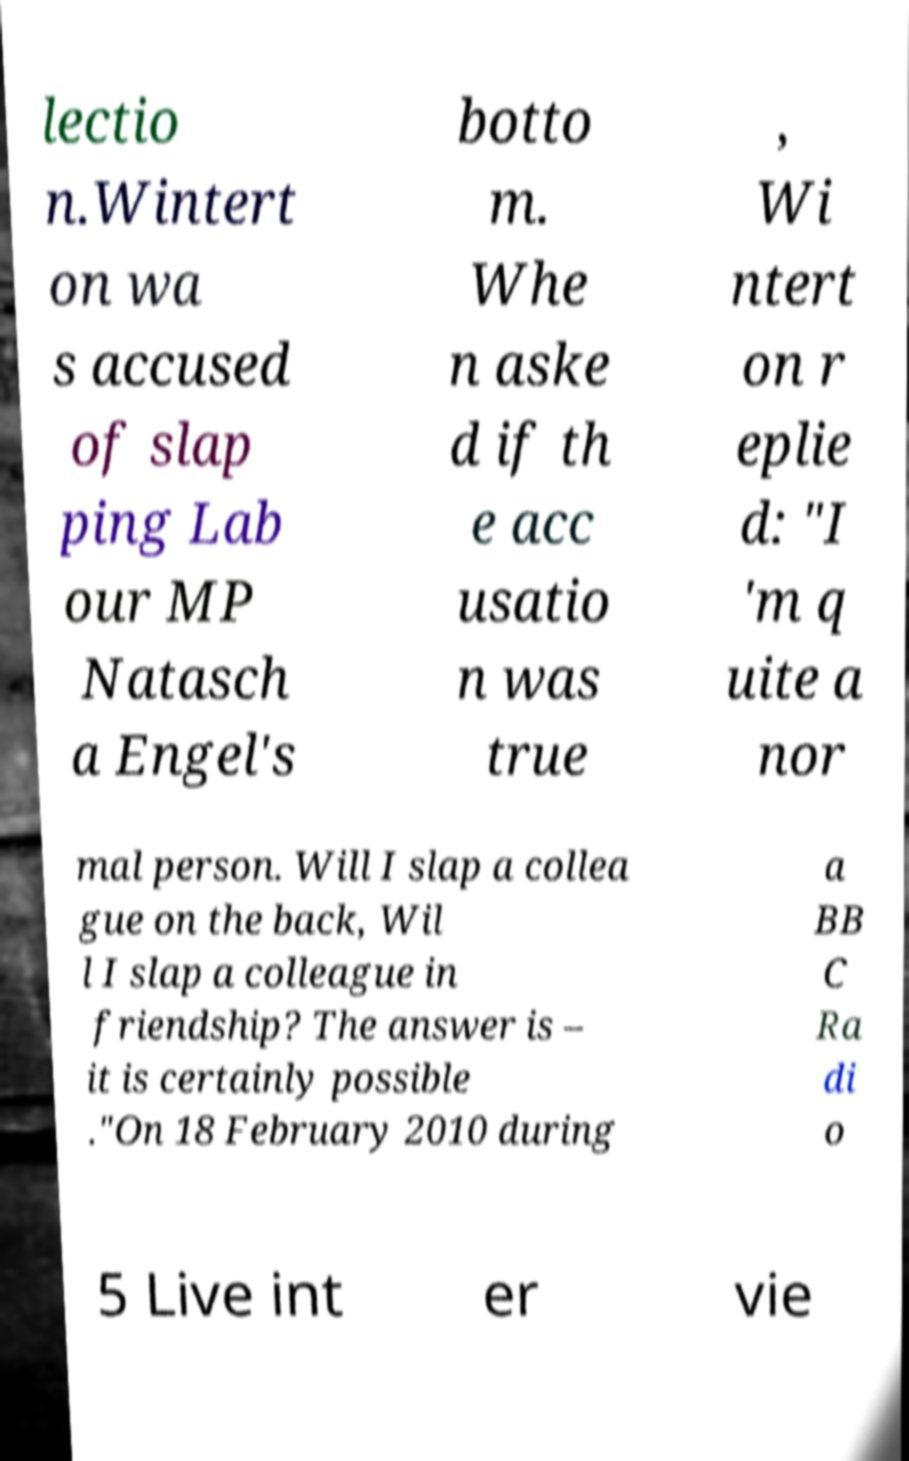Could you assist in decoding the text presented in this image and type it out clearly? lectio n.Wintert on wa s accused of slap ping Lab our MP Natasch a Engel's botto m. Whe n aske d if th e acc usatio n was true , Wi ntert on r eplie d: "I 'm q uite a nor mal person. Will I slap a collea gue on the back, Wil l I slap a colleague in friendship? The answer is – it is certainly possible ."On 18 February 2010 during a BB C Ra di o 5 Live int er vie 